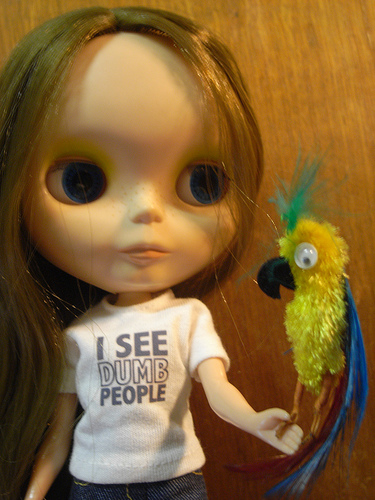<image>
Is there a doll above the bird? No. The doll is not positioned above the bird. The vertical arrangement shows a different relationship. 